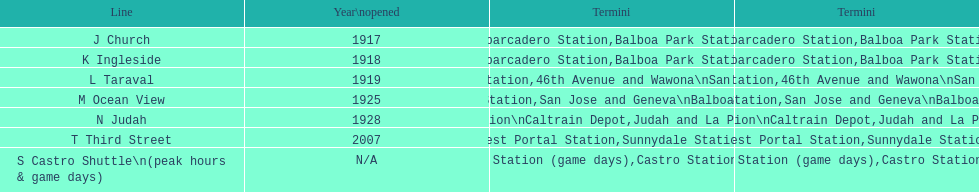Which line should you choose to use during game days? S Castro Shuttle. 